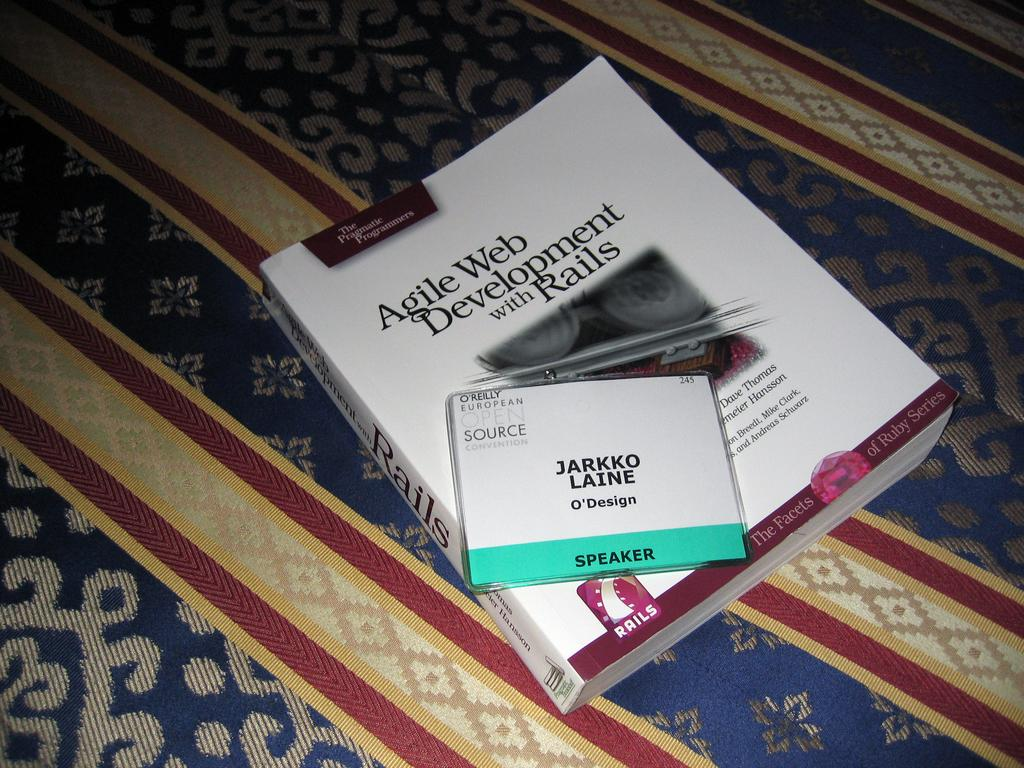<image>
Relay a brief, clear account of the picture shown. A book titled Agile Web Development with a nametag on it. 